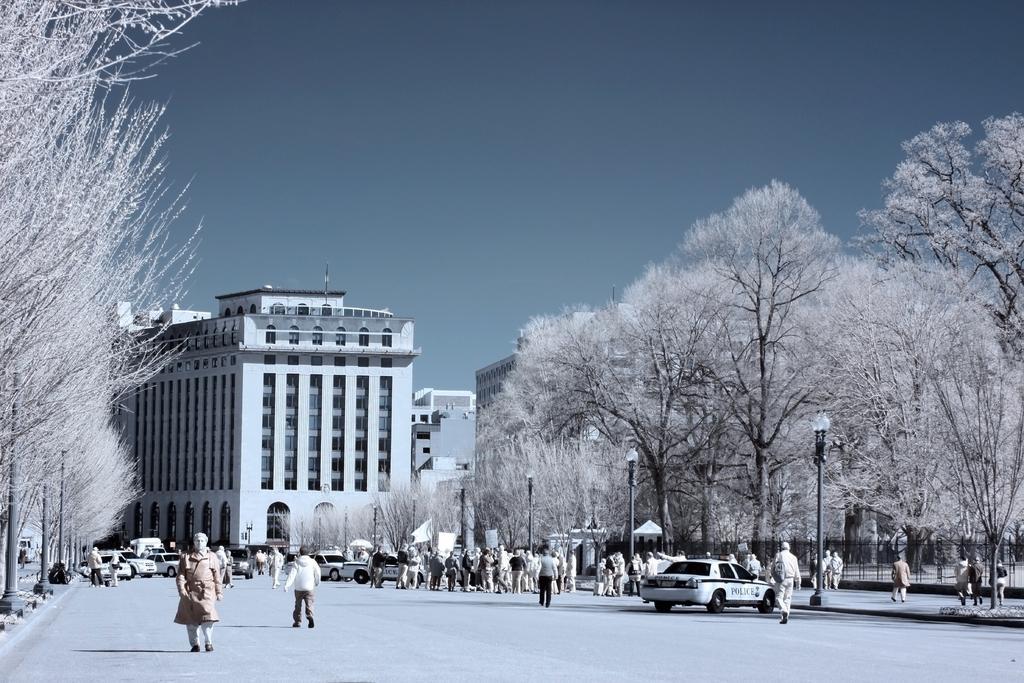Describe this image in one or two sentences. On the left side a person is walking on the road. On the right side a police vehicle is parked on the road and there are trees. In the middle it is a very big building, at the top it's a sky. 